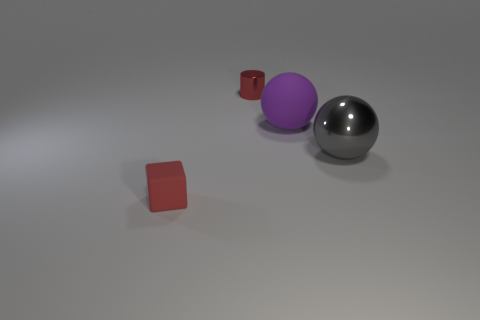Add 3 tiny red shiny things. How many objects exist? 7 Subtract all blocks. How many objects are left? 3 Add 4 large green rubber things. How many large green rubber things exist? 4 Subtract 1 red cylinders. How many objects are left? 3 Subtract all tiny metal cylinders. Subtract all tiny red cubes. How many objects are left? 2 Add 4 metal objects. How many metal objects are left? 6 